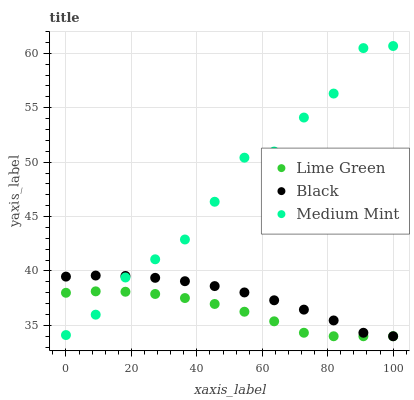Does Lime Green have the minimum area under the curve?
Answer yes or no. Yes. Does Medium Mint have the maximum area under the curve?
Answer yes or no. Yes. Does Black have the minimum area under the curve?
Answer yes or no. No. Does Black have the maximum area under the curve?
Answer yes or no. No. Is Black the smoothest?
Answer yes or no. Yes. Is Medium Mint the roughest?
Answer yes or no. Yes. Is Lime Green the smoothest?
Answer yes or no. No. Is Lime Green the roughest?
Answer yes or no. No. Does Black have the lowest value?
Answer yes or no. Yes. Does Medium Mint have the highest value?
Answer yes or no. Yes. Does Black have the highest value?
Answer yes or no. No. Does Medium Mint intersect Black?
Answer yes or no. Yes. Is Medium Mint less than Black?
Answer yes or no. No. Is Medium Mint greater than Black?
Answer yes or no. No. 